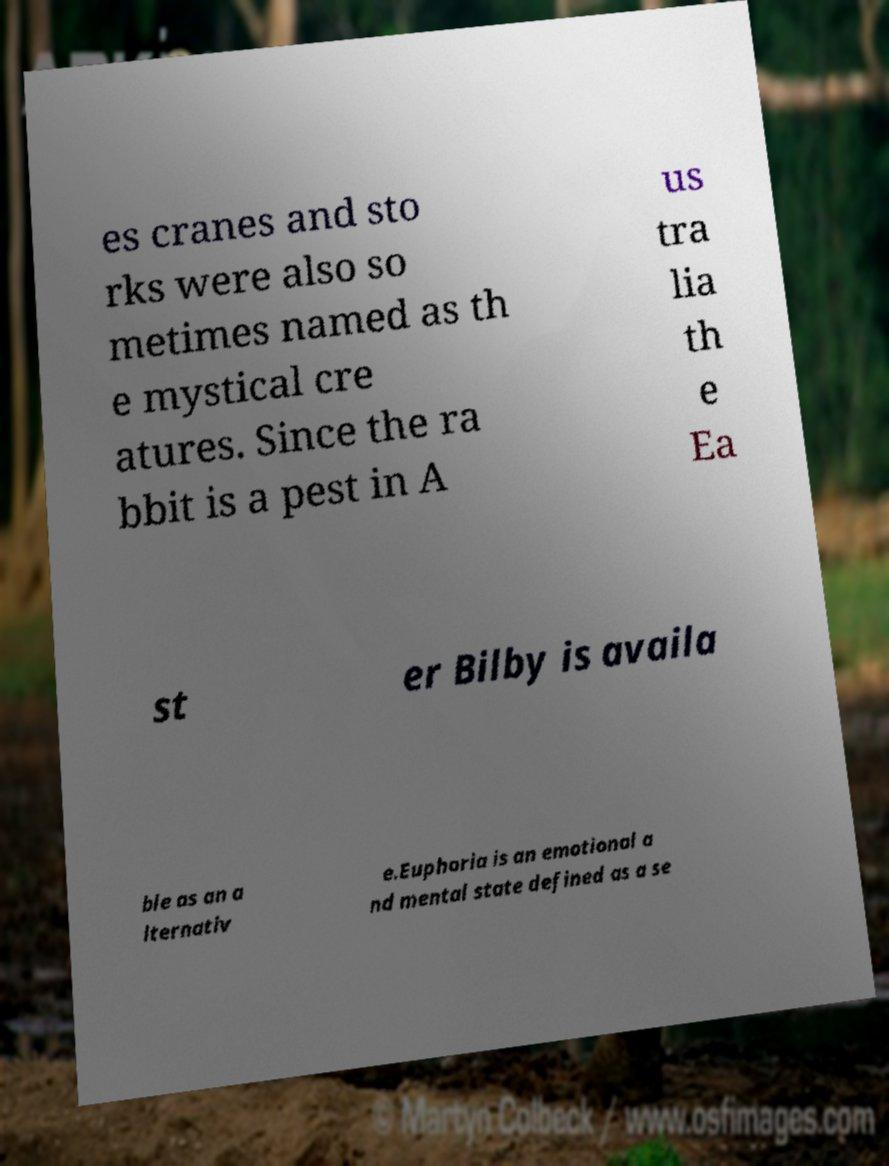For documentation purposes, I need the text within this image transcribed. Could you provide that? es cranes and sto rks were also so metimes named as th e mystical cre atures. Since the ra bbit is a pest in A us tra lia th e Ea st er Bilby is availa ble as an a lternativ e.Euphoria is an emotional a nd mental state defined as a se 